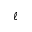<formula> <loc_0><loc_0><loc_500><loc_500>\ell</formula> 